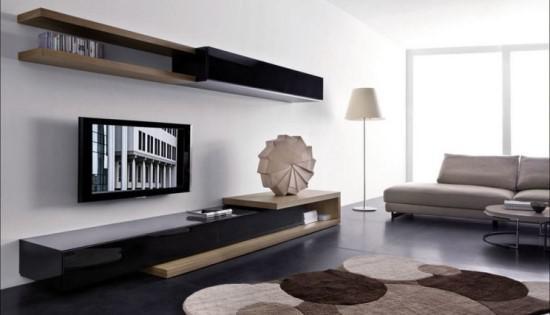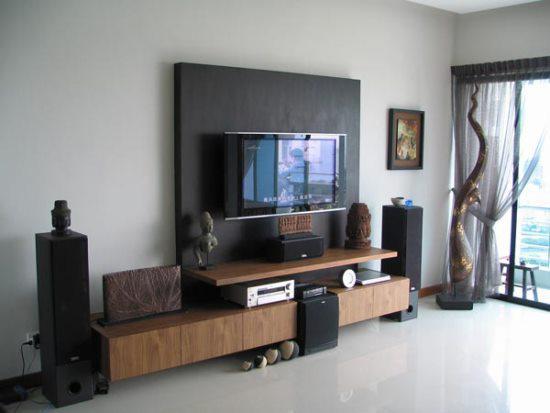The first image is the image on the left, the second image is the image on the right. For the images displayed, is the sentence "In at least one image there is a TV mounted to a shelf with a tall back over a long cabinet." factually correct? Answer yes or no. Yes. The first image is the image on the left, the second image is the image on the right. Evaluate the accuracy of this statement regarding the images: "At least one television is on.". Is it true? Answer yes or no. Yes. 